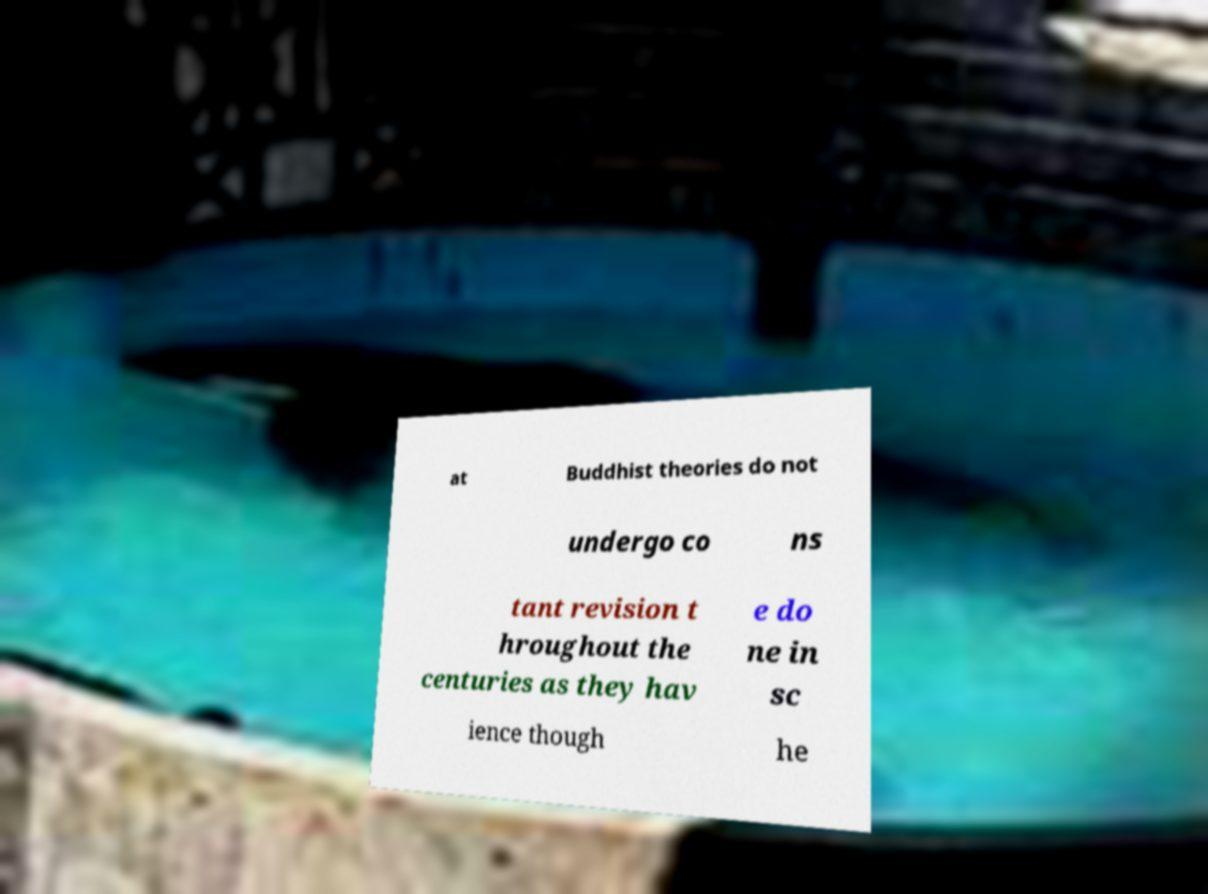Could you extract and type out the text from this image? at Buddhist theories do not undergo co ns tant revision t hroughout the centuries as they hav e do ne in sc ience though he 